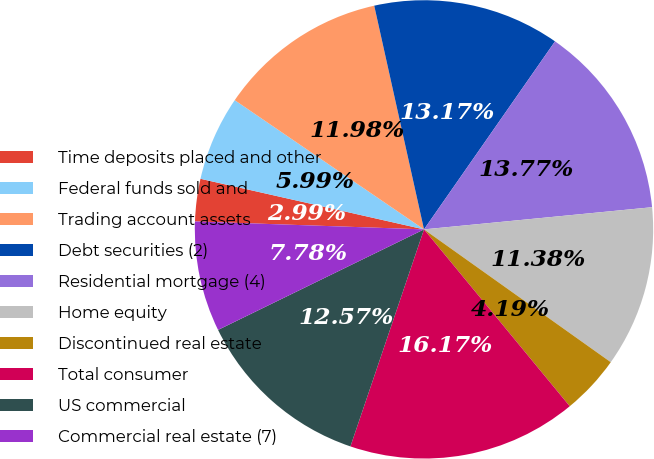Convert chart. <chart><loc_0><loc_0><loc_500><loc_500><pie_chart><fcel>Time deposits placed and other<fcel>Federal funds sold and<fcel>Trading account assets<fcel>Debt securities (2)<fcel>Residential mortgage (4)<fcel>Home equity<fcel>Discontinued real estate<fcel>Total consumer<fcel>US commercial<fcel>Commercial real estate (7)<nl><fcel>2.99%<fcel>5.99%<fcel>11.98%<fcel>13.17%<fcel>13.77%<fcel>11.38%<fcel>4.19%<fcel>16.17%<fcel>12.57%<fcel>7.78%<nl></chart> 